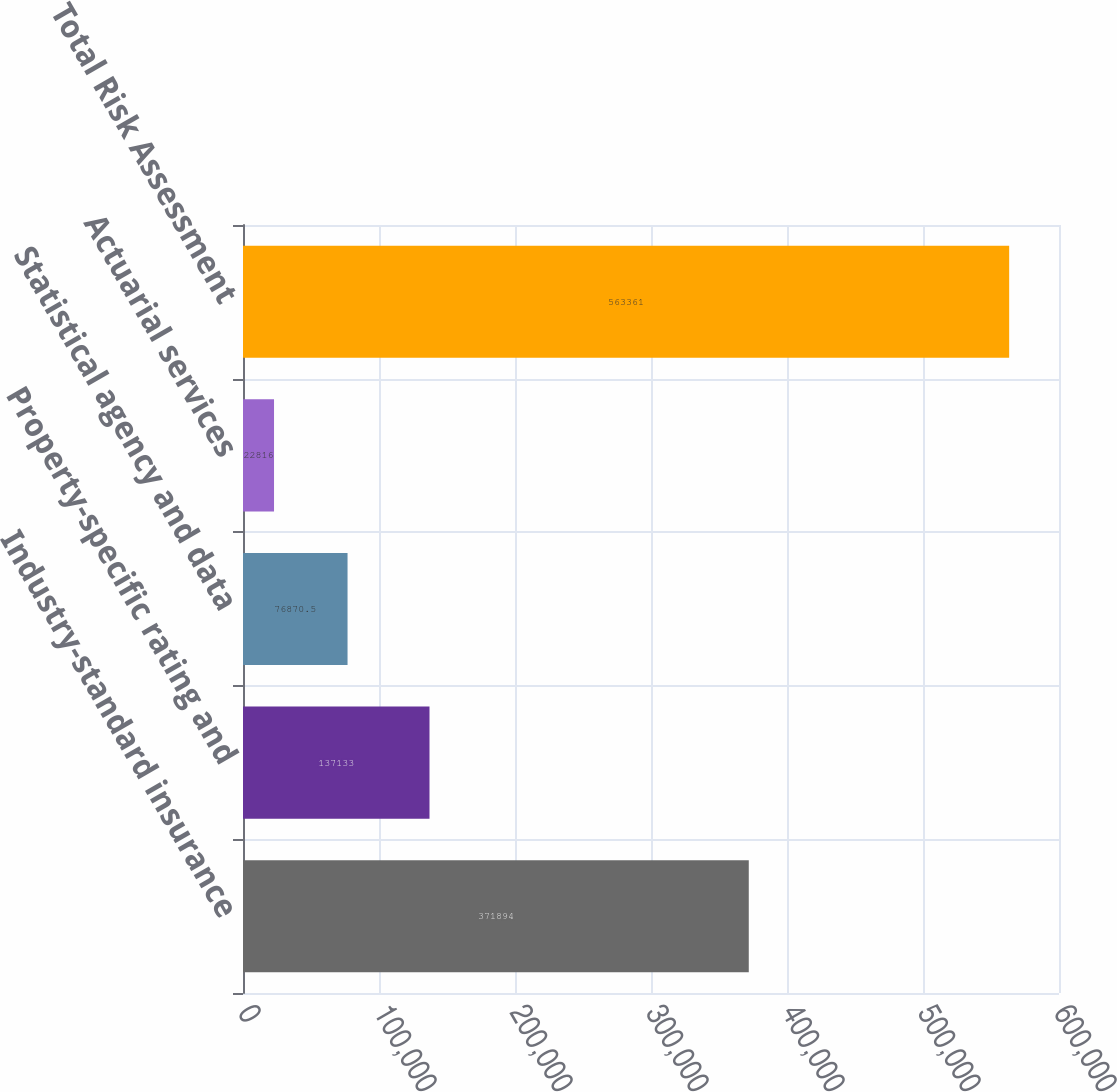Convert chart to OTSL. <chart><loc_0><loc_0><loc_500><loc_500><bar_chart><fcel>Industry-standard insurance<fcel>Property-specific rating and<fcel>Statistical agency and data<fcel>Actuarial services<fcel>Total Risk Assessment<nl><fcel>371894<fcel>137133<fcel>76870.5<fcel>22816<fcel>563361<nl></chart> 